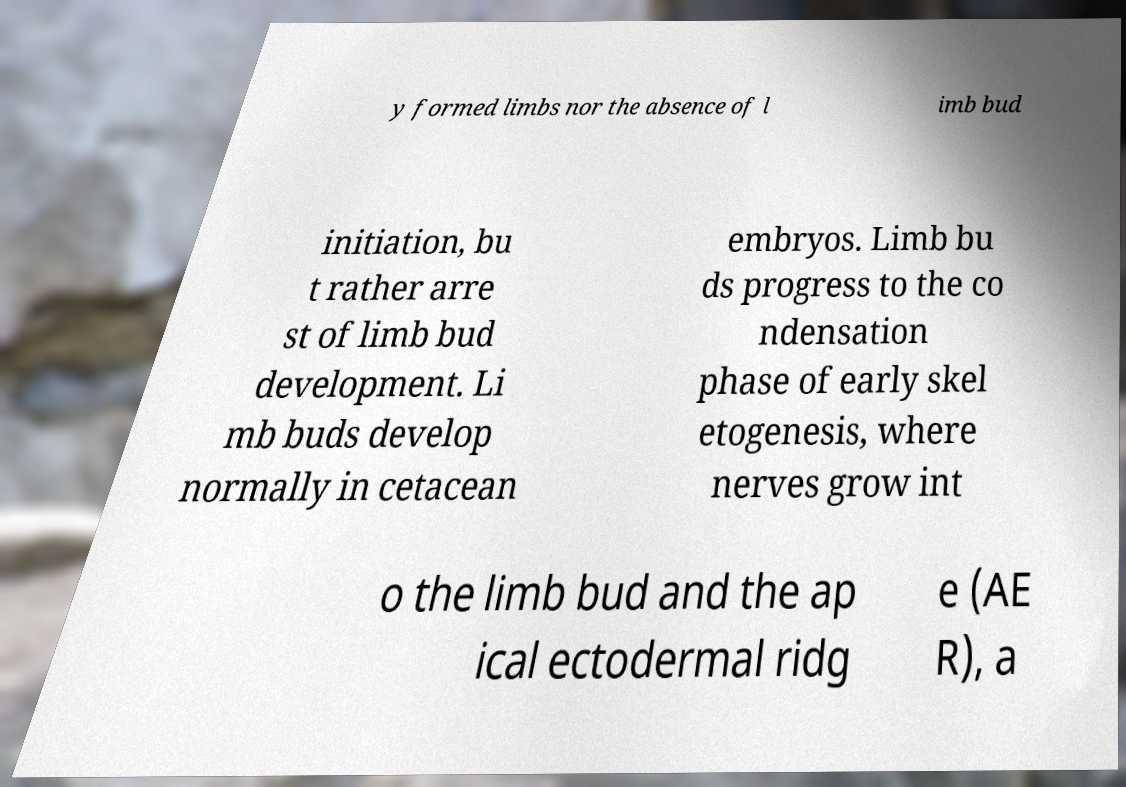Can you read and provide the text displayed in the image?This photo seems to have some interesting text. Can you extract and type it out for me? y formed limbs nor the absence of l imb bud initiation, bu t rather arre st of limb bud development. Li mb buds develop normally in cetacean embryos. Limb bu ds progress to the co ndensation phase of early skel etogenesis, where nerves grow int o the limb bud and the ap ical ectodermal ridg e (AE R), a 